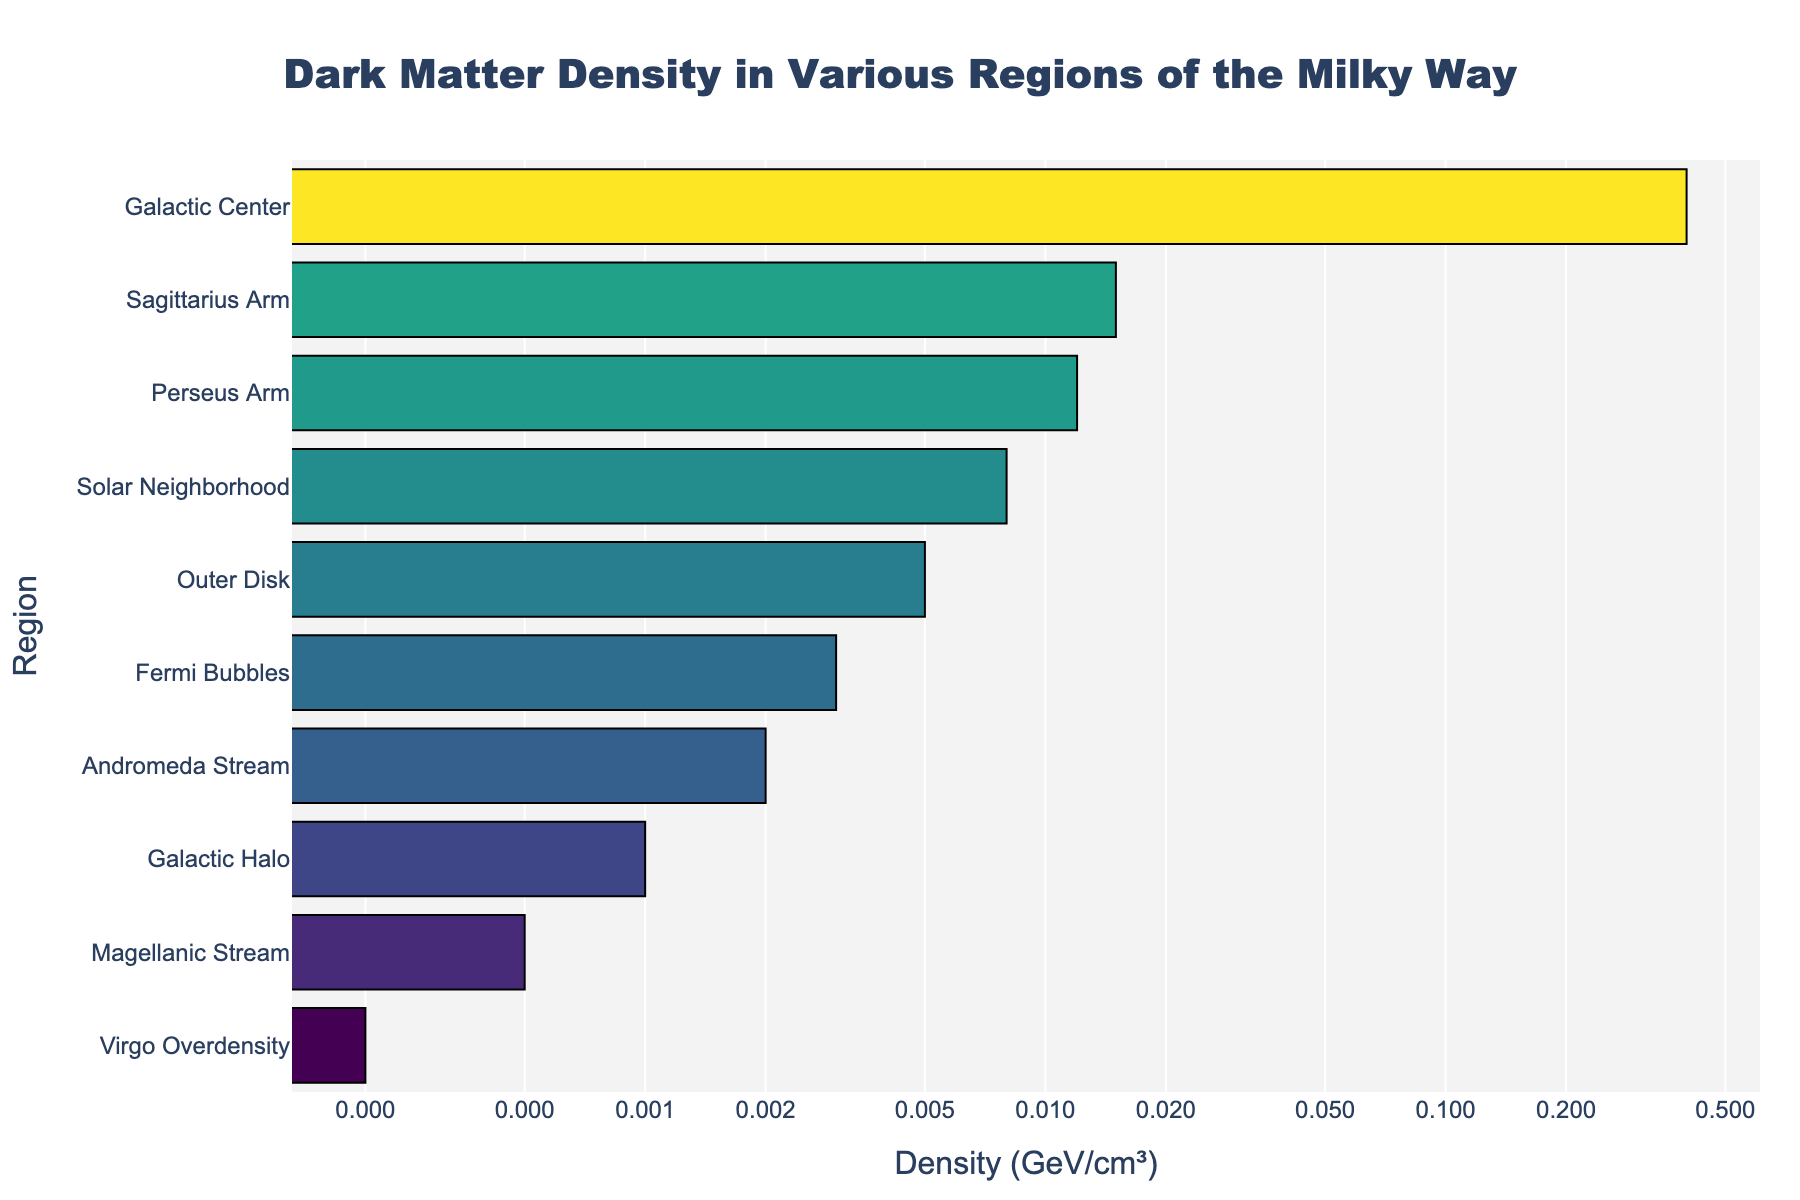What is the title of the plot? The title is usually prominently displayed at the top of the figure. In this case, it reads 'Dark Matter Density in Various Regions of the Milky Way'.
Answer: Dark Matter Density in Various Regions of the Milky Way Which region has the highest dark matter density? By observing the horizontal bars, the region with the longest bar representing the highest density value is the Galactic Center.
Answer: Galactic Center How many regions are shown in the plot? Count the number of unique labels on the y-axis that represent different regions. There are 10 regions listed in the data.
Answer: 10 Which regions have a dark matter density lower than 0.005 GeV/cm³? Identify all the horizontal bars with an x-value less than 0.005 GeV/cm³. These regions are: Andromeda Stream, Galactic Halo, Fermi Bubbles, Magellanic Stream, and Virgo Overdensity.
Answer: Andromeda Stream, Galactic Halo, Fermi Bubbles, Magellanic Stream, Virgo Overdensity What is the median dark matter density value of the regions? Sort the density values, and find the middle value. The sorted density values are 0.0002, 0.0005, 0.001, 0.002, 0.003, 0.005, 0.008, 0.012, 0.015, 0.4. The median of these values is the average of the 5th and 6th values: (0.003 + 0.005) / 2 = 0.004.
Answer: 0.004 Which region has the third lowest dark matter density? Sort regions by density in ascending order and locate the third entry. The sorted densities are: 0.0002 (Virgo Overdensity), 0.0005 (Magellanic Stream), and 0.001 (Galactic Halo). Therefore, the Galactic Halo has the third lowest density.
Answer: Galactic Halo Is the dark matter density in the Solar Neighborhood higher or lower than in the Outer Disk? Compare the x-values of the respective horizontal bars. The Solar Neighborhood has a density of 0.008 GeV/cm³, while the Outer Disk has 0.005 GeV/cm³. 0.008 is greater than 0.005.
Answer: Higher Which region has a density of 0.002 GeV/cm³? Locate the horizontal bar that has an x-value of 0.002 GeV/cm³. The region corresponding to this value is the Andromeda Stream.
Answer: Andromeda Stream What is the total dark matter density of the Sagittarius Arm and Perseus Arm combined? Sum the density values of the two regions: 0.015 GeV/cm³ for Sagittarius Arm and 0.012 GeV/cm³ for Perseus Arm. 0.015 + 0.012 = 0.027.
Answer: 0.027 What color represents the highest density value in the plot? The color of the bars corresponds to the logarithm of the density values on a Viridis color scale. The bar with the highest log density value will be found at the top of the color gradient, typically yellow.
Answer: Yellow 